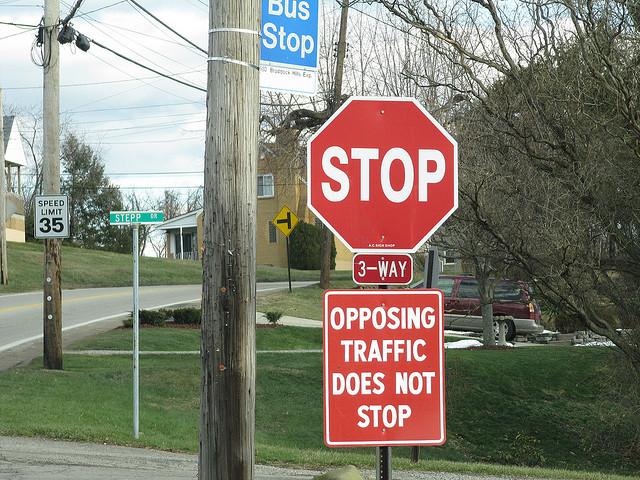What color is the building in the background?
Short answer required. Yellow. Is this how the stop sign was originally intended to look?
Write a very short answer. Yes. What is the speed limit?
Answer briefly. 35. What country is this?
Answer briefly. Usa. 